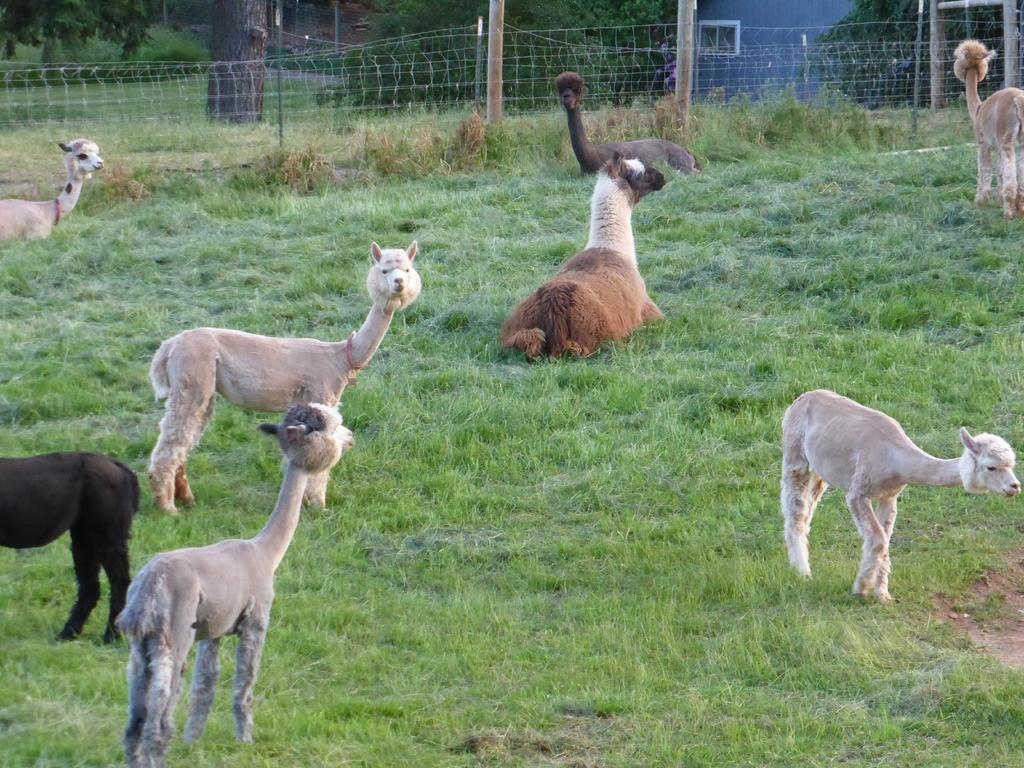Please provide a concise description of this image. In this image we can see a few animals on the ground, there are some trees, grass, poles and fence. 